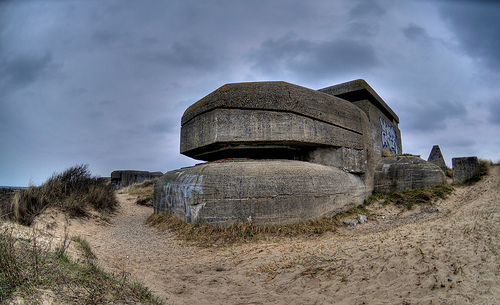<image>
Can you confirm if the sky is behind the rock? Yes. From this viewpoint, the sky is positioned behind the rock, with the rock partially or fully occluding the sky. 